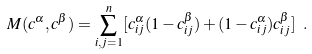<formula> <loc_0><loc_0><loc_500><loc_500>M ( { c } ^ { \alpha } , { c } ^ { \beta } ) = \sum _ { i , j = 1 } ^ { n } [ c _ { i j } ^ { \alpha } ( 1 - c _ { i j } ^ { \beta } ) + ( 1 - c _ { i j } ^ { \alpha } ) c _ { i j } ^ { \beta } ] \ .</formula> 